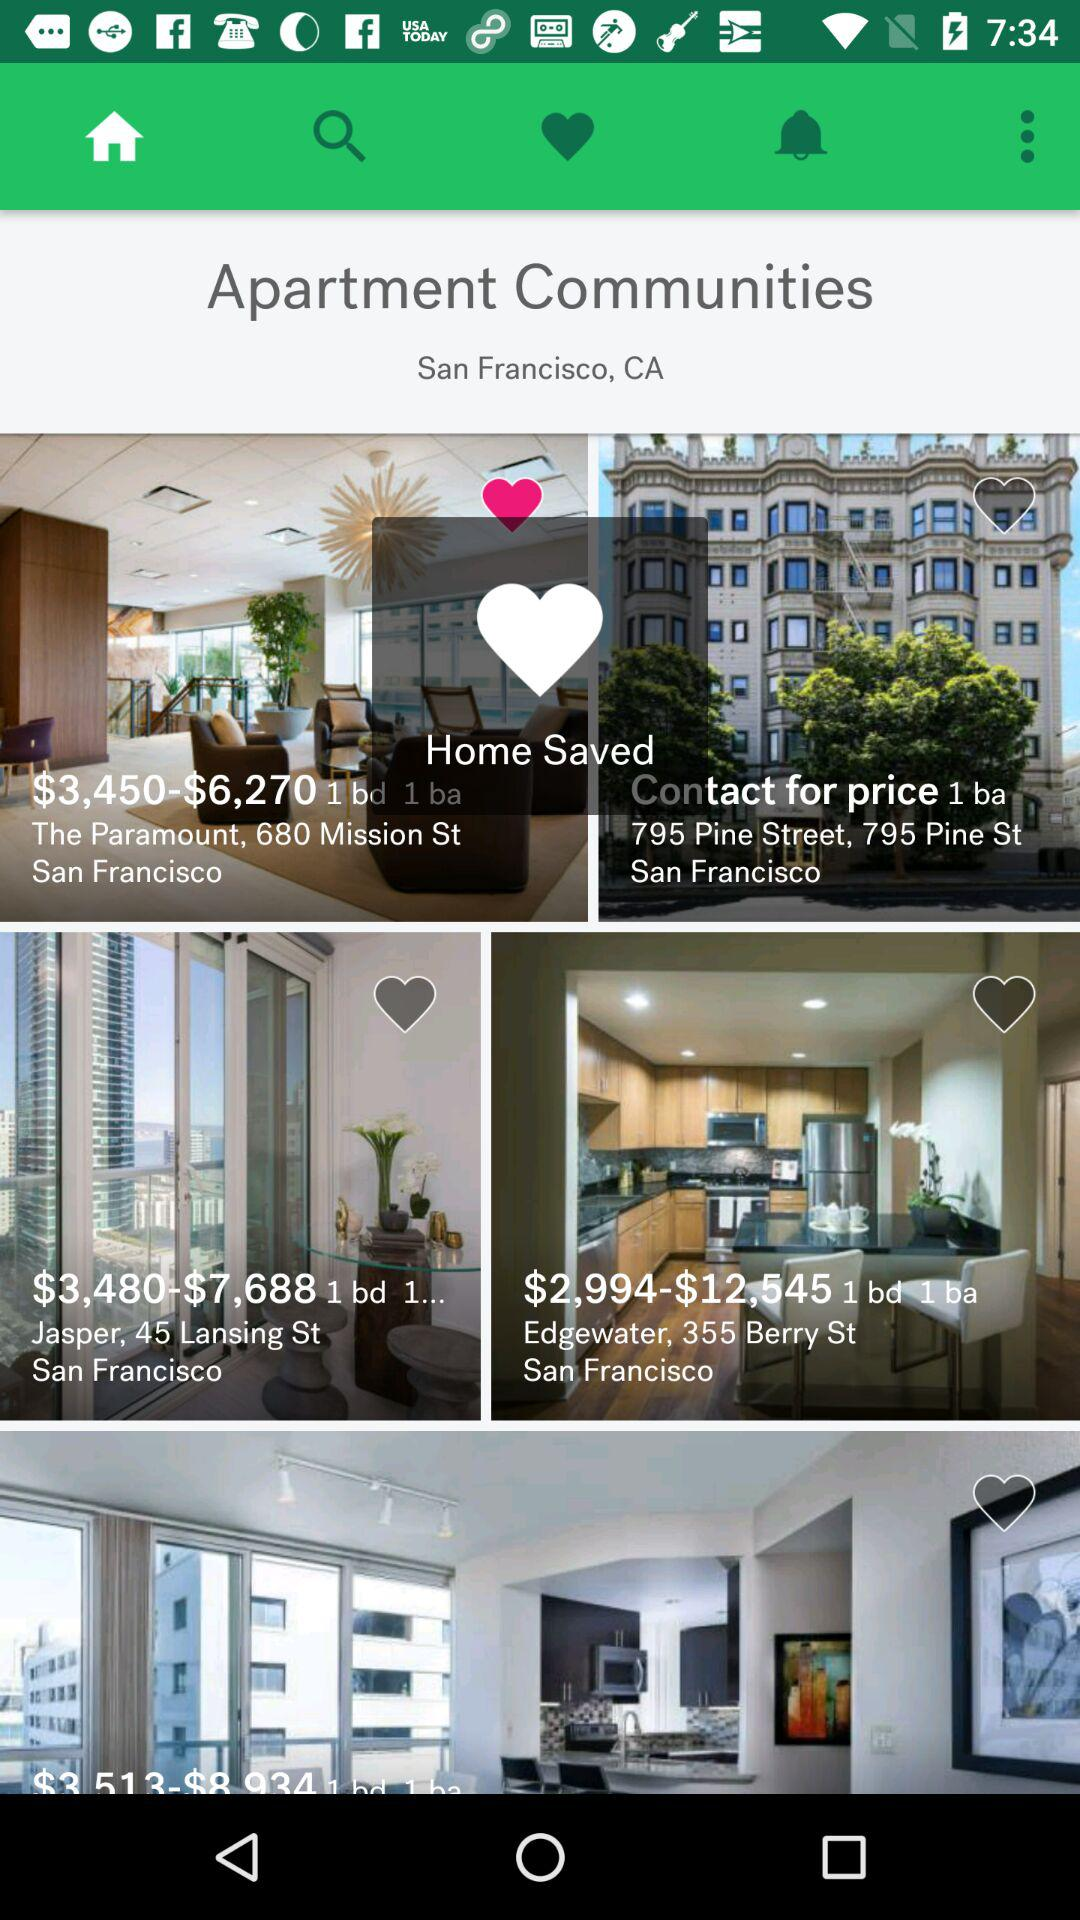What's the price range of an apartment located in "Edgewater, 355 Berry St San Francisco"? The price range is from $2,994 to $12,545. 